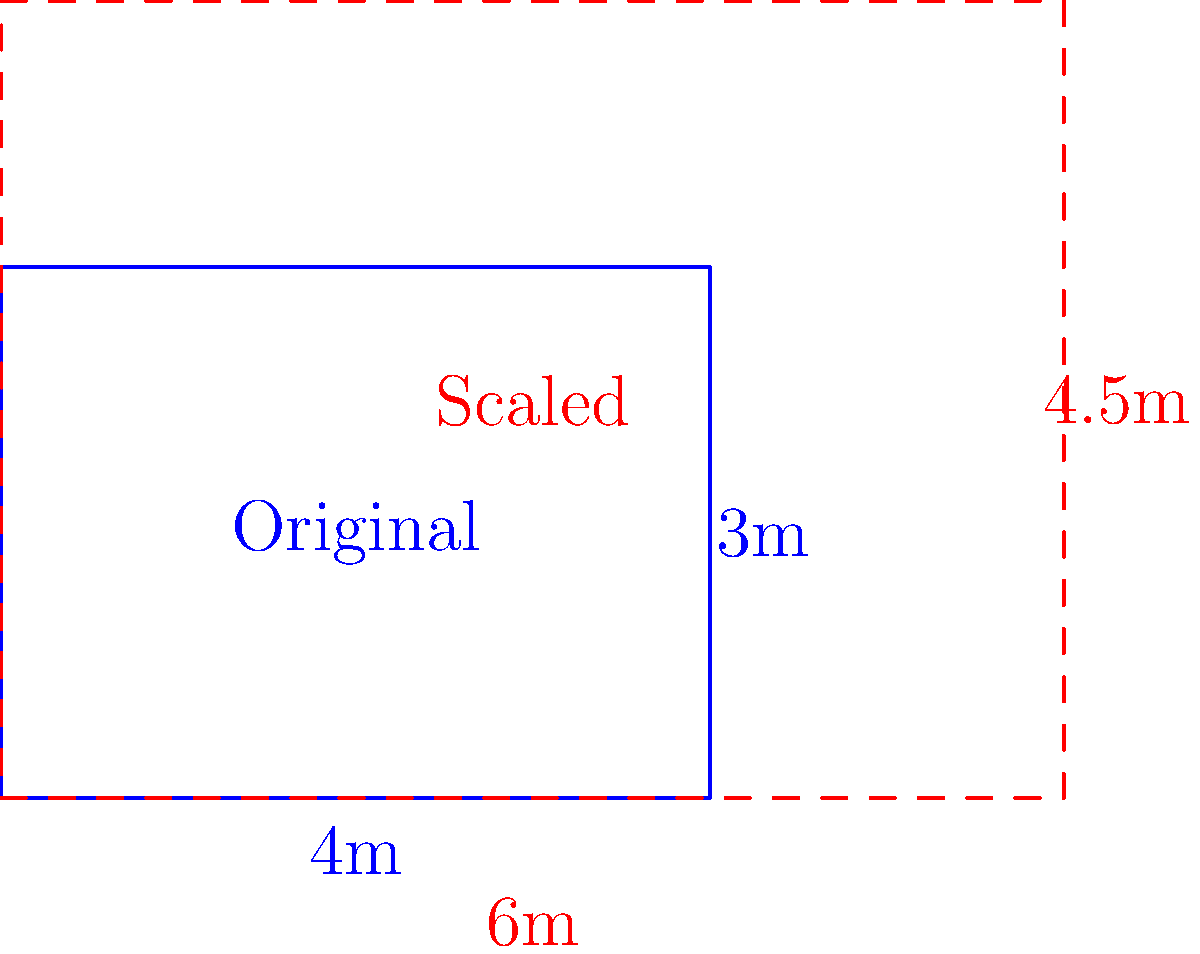A spacecraft's heat shield needs to be scaled up for a new mission. The original rectangular heat shield measures 4m by 3m. If the new heat shield is scaled uniformly so that its width is now 6m, what is the area of the new heat shield in square meters? Let's approach this step-by-step:

1) First, we need to determine the scale factor. We can do this by comparing the new width to the original width:
   Scale factor = New width / Original width
   $$ \text{Scale factor} = \frac{6\text{m}}{4\text{m}} = 1.5 $$

2) Since the scaling is uniform, this factor applies to both dimensions. So the new height will be:
   New height = Original height × Scale factor
   $$ \text{New height} = 3\text{m} \times 1.5 = 4.5\text{m} $$

3) Now we know the dimensions of the new heat shield: 6m × 4.5m

4) To find the area, we multiply these dimensions:
   $$ \text{New Area} = 6\text{m} \times 4.5\text{m} = 27\text{m}^2 $$

5) We can verify this result using the scale factor squared:
   New Area = Original Area × (Scale factor)²
   $$ \text{New Area} = (4\text{m} \times 3\text{m}) \times 1.5^2 = 12\text{m}^2 \times 2.25 = 27\text{m}^2 $$

Thus, the area of the new heat shield is 27 square meters.
Answer: 27 m² 